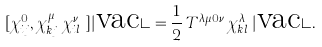Convert formula to latex. <formula><loc_0><loc_0><loc_500><loc_500>[ \chi ^ { 0 } _ { i j } , \chi ^ { \mu \dagger } _ { k j } \chi ^ { \nu \dagger } _ { i l } ] | \text {vac} \rangle = \frac { 1 } { 2 } \, T ^ { \lambda \mu 0 \nu } \, \chi ^ { \lambda \dagger } _ { k l } | \text {vac} \rangle .</formula> 